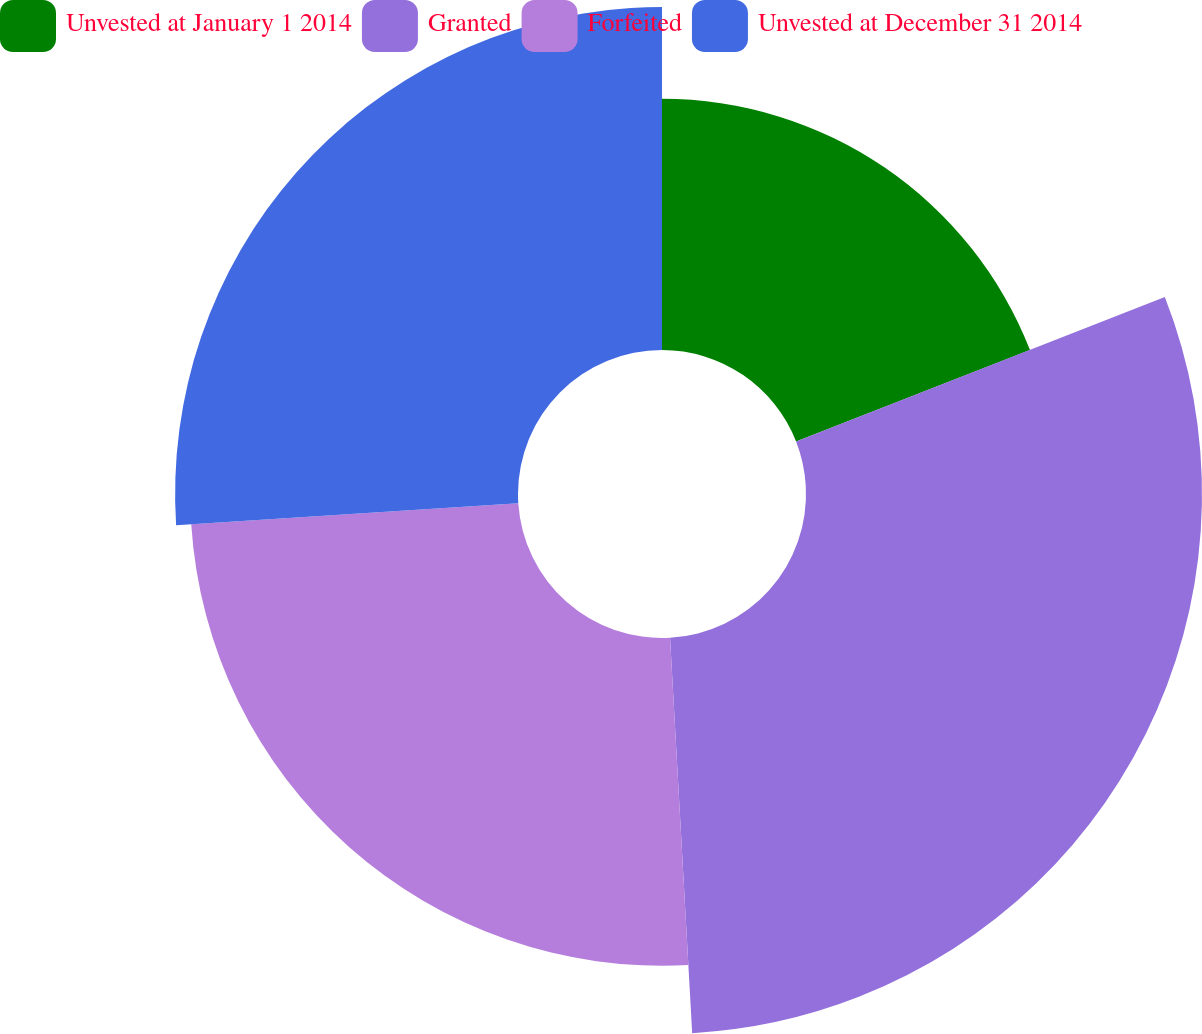Convert chart to OTSL. <chart><loc_0><loc_0><loc_500><loc_500><pie_chart><fcel>Unvested at January 1 2014<fcel>Granted<fcel>Forfeited<fcel>Unvested at December 31 2014<nl><fcel>19.06%<fcel>30.05%<fcel>24.87%<fcel>26.02%<nl></chart> 